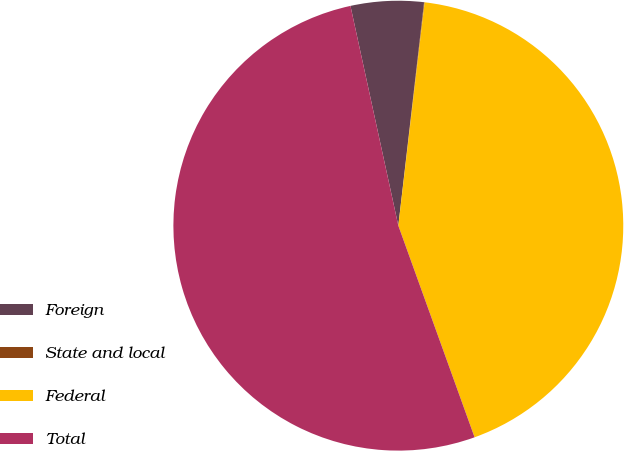Convert chart to OTSL. <chart><loc_0><loc_0><loc_500><loc_500><pie_chart><fcel>Foreign<fcel>State and local<fcel>Federal<fcel>Total<nl><fcel>5.24%<fcel>0.04%<fcel>42.63%<fcel>52.09%<nl></chart> 